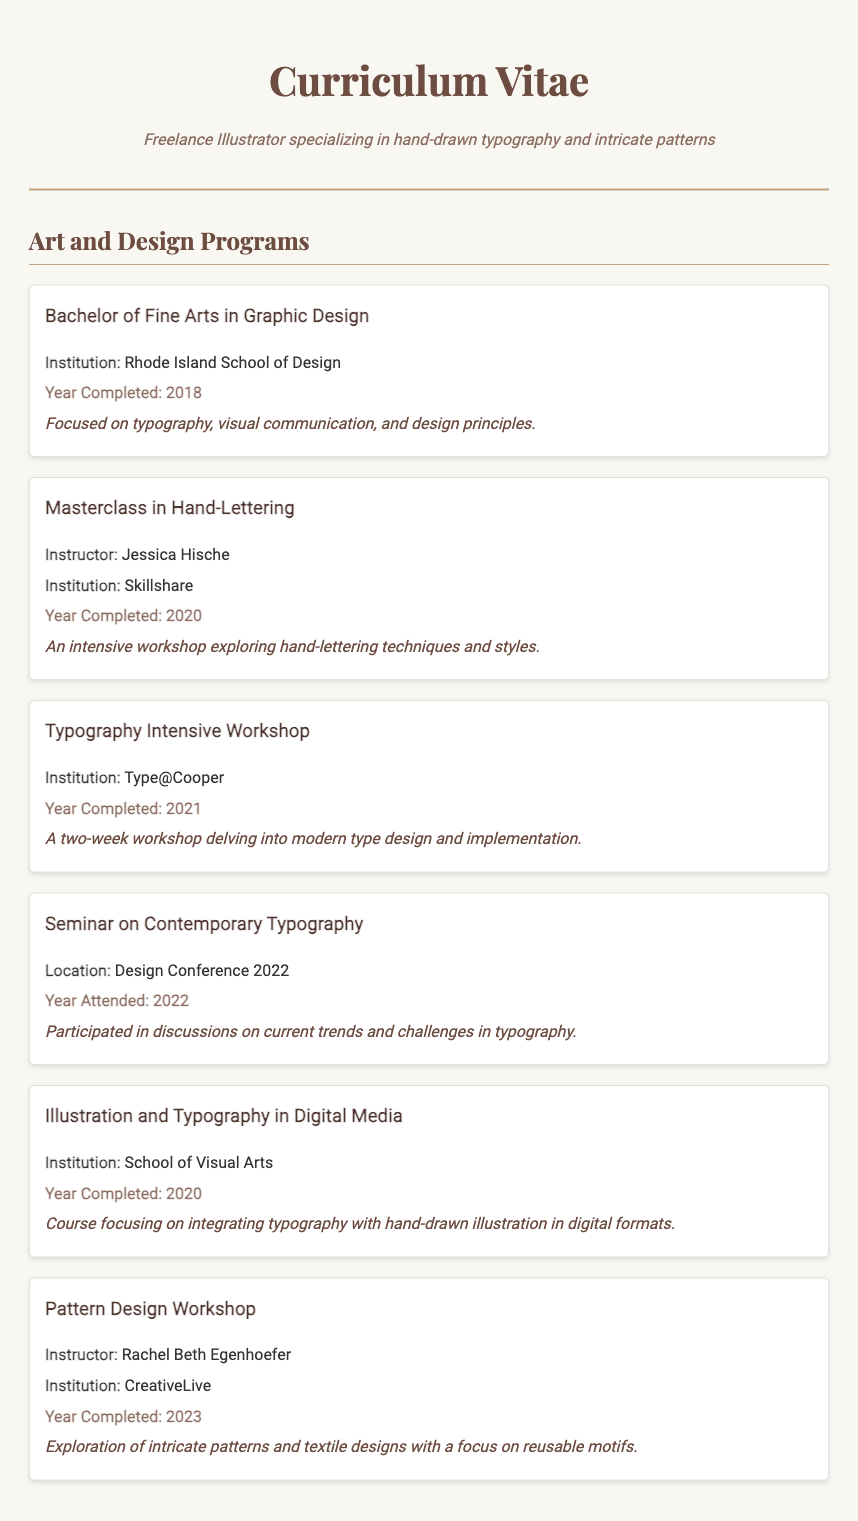What is the degree earned? The document states that the degree earned is a Bachelor of Fine Arts in Graphic Design.
Answer: Bachelor of Fine Arts in Graphic Design Who was the instructor for the Masterclass in Hand-Lettering? The document specifies that Jessica Hische was the instructor for this masterclass.
Answer: Jessica Hische What year was the Typography Intensive Workshop completed? The year of completion for the Typography Intensive Workshop is stated as 2021.
Answer: 2021 What institution offered the seminar on Contemporary Typography? The document lists the location of the seminar as Design Conference 2022, not a specific institution.
Answer: Design Conference 2022 Which course focuses on integrating typography with illustration? The course mentioned in the document that integrates typography with illustration is "Illustration and Typography in Digital Media."
Answer: Illustration and Typography in Digital Media What is the focus of the Pattern Design Workshop? The document explains the focus of the workshop is on intricate patterns and textile designs.
Answer: Intricate patterns and textile designs How many workshops or seminars related to Typography are listed? The document presents a total of six programs including workshops and seminars related to typography.
Answer: 6 What year was the Pattern Design Workshop completed? The completion year for the Pattern Design Workshop is stated as 2023.
Answer: 2023 Which institution is associated with the course on Illustration and Typography in Digital Media? According to the document, the institution associated with this course is the School of Visual Arts.
Answer: School of Visual Arts 